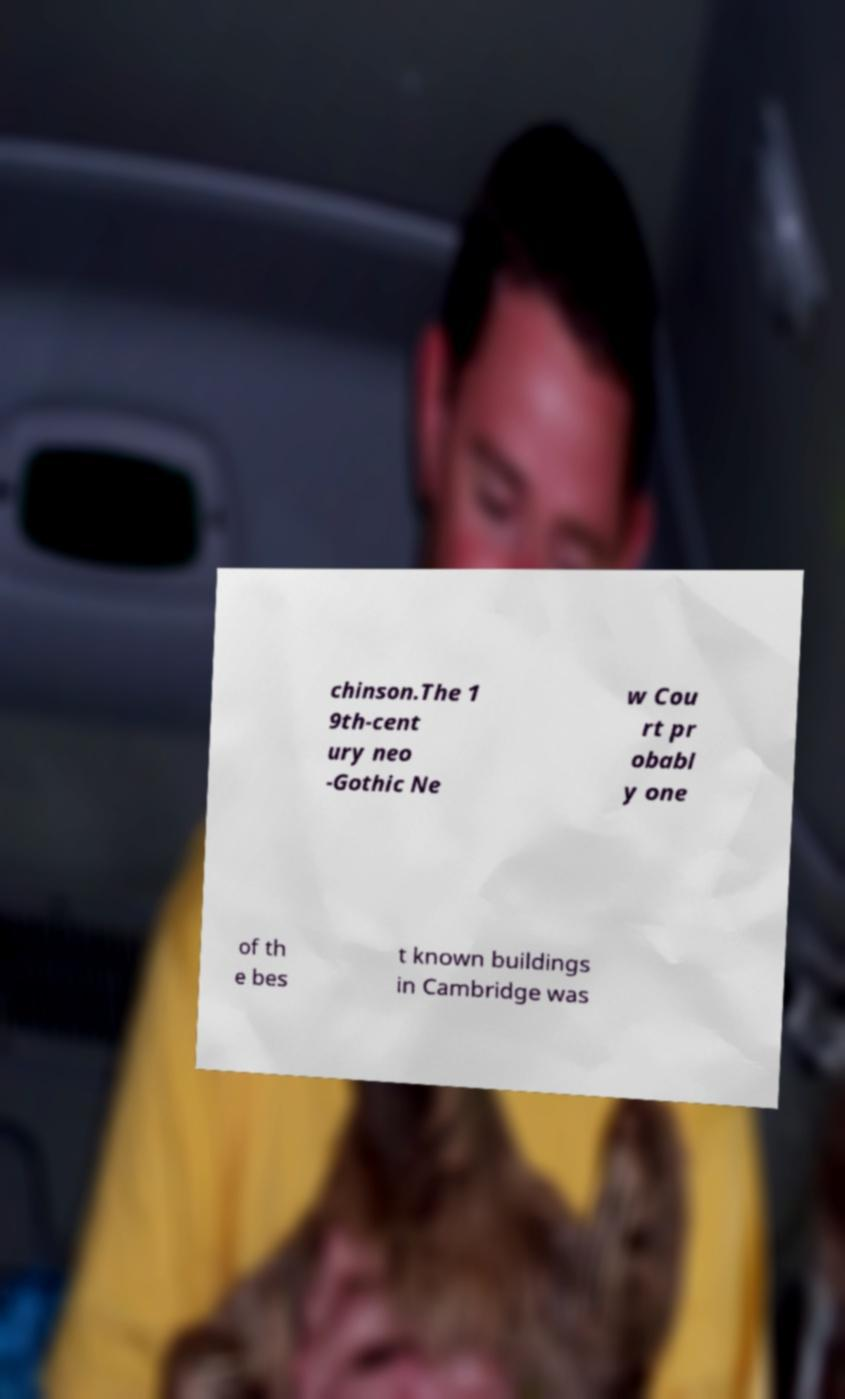Please identify and transcribe the text found in this image. chinson.The 1 9th-cent ury neo -Gothic Ne w Cou rt pr obabl y one of th e bes t known buildings in Cambridge was 